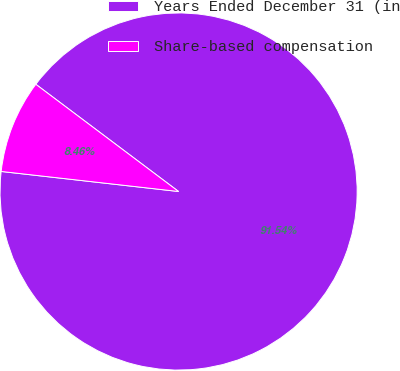<chart> <loc_0><loc_0><loc_500><loc_500><pie_chart><fcel>Years Ended December 31 (in<fcel>Share-based compensation<nl><fcel>91.54%<fcel>8.46%<nl></chart> 